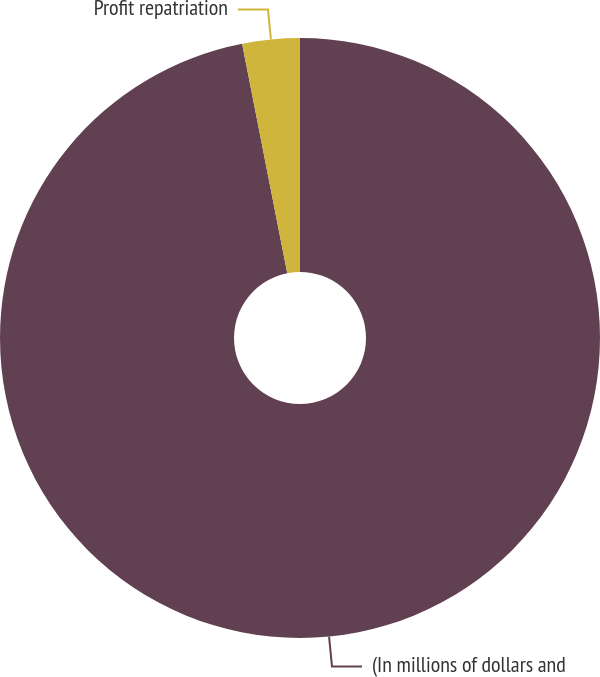Convert chart. <chart><loc_0><loc_0><loc_500><loc_500><pie_chart><fcel>(In millions of dollars and<fcel>Profit repatriation<nl><fcel>96.91%<fcel>3.09%<nl></chart> 